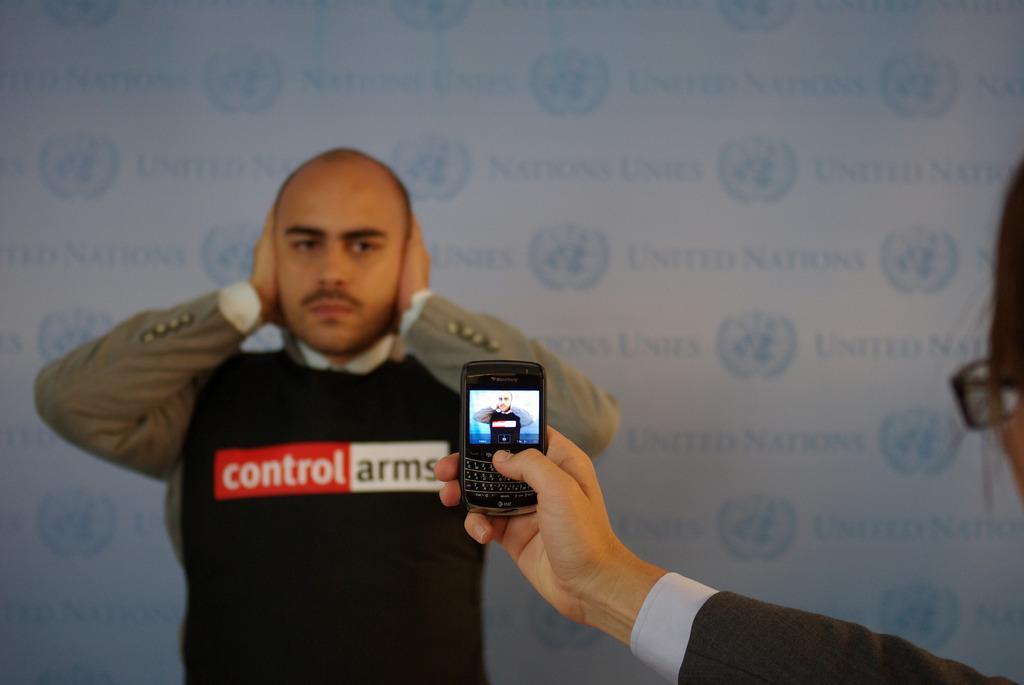Could you give a brief overview of what you see in this image? In this image i can see a woman holding a mobile and at the back ground i can see a man standing and a wall. 